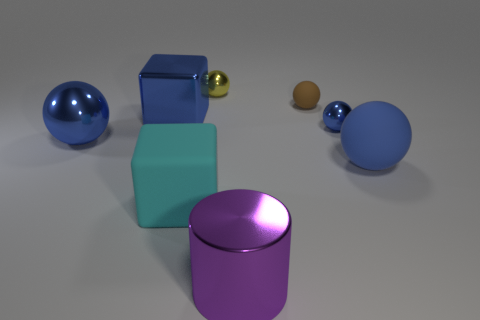How many blue spheres must be subtracted to get 1 blue spheres? 2 Add 1 large green shiny cubes. How many objects exist? 9 Subtract all blue metallic spheres. How many spheres are left? 3 Subtract all gray cylinders. How many blue balls are left? 3 Subtract 2 balls. How many balls are left? 3 Subtract all yellow spheres. How many spheres are left? 4 Subtract all blocks. How many objects are left? 6 Subtract all yellow spheres. Subtract all gray cylinders. How many spheres are left? 4 Add 8 purple metallic things. How many purple metallic things exist? 9 Subtract 0 gray balls. How many objects are left? 8 